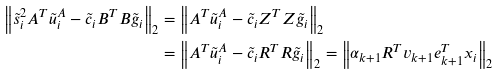<formula> <loc_0><loc_0><loc_500><loc_500>\left \| \tilde { s } _ { i } ^ { 2 } A ^ { T } \tilde { u } _ { i } ^ { A } - \tilde { c } _ { i } B ^ { T } B \tilde { g } _ { i } \right \| _ { 2 } & = \left \| A ^ { T } \tilde { u } _ { i } ^ { A } - \tilde { c } _ { i } Z ^ { T } Z \tilde { g } _ { i } \right \| _ { 2 } \\ & = \left \| A ^ { T } \tilde { u } _ { i } ^ { A } - \tilde { c } _ { i } R ^ { T } R \tilde { g } _ { i } \right \| _ { 2 } = \left \| \alpha _ { k + 1 } R ^ { T } v _ { k + 1 } e _ { k + 1 } ^ { T } x _ { i } \right \| _ { 2 }</formula> 